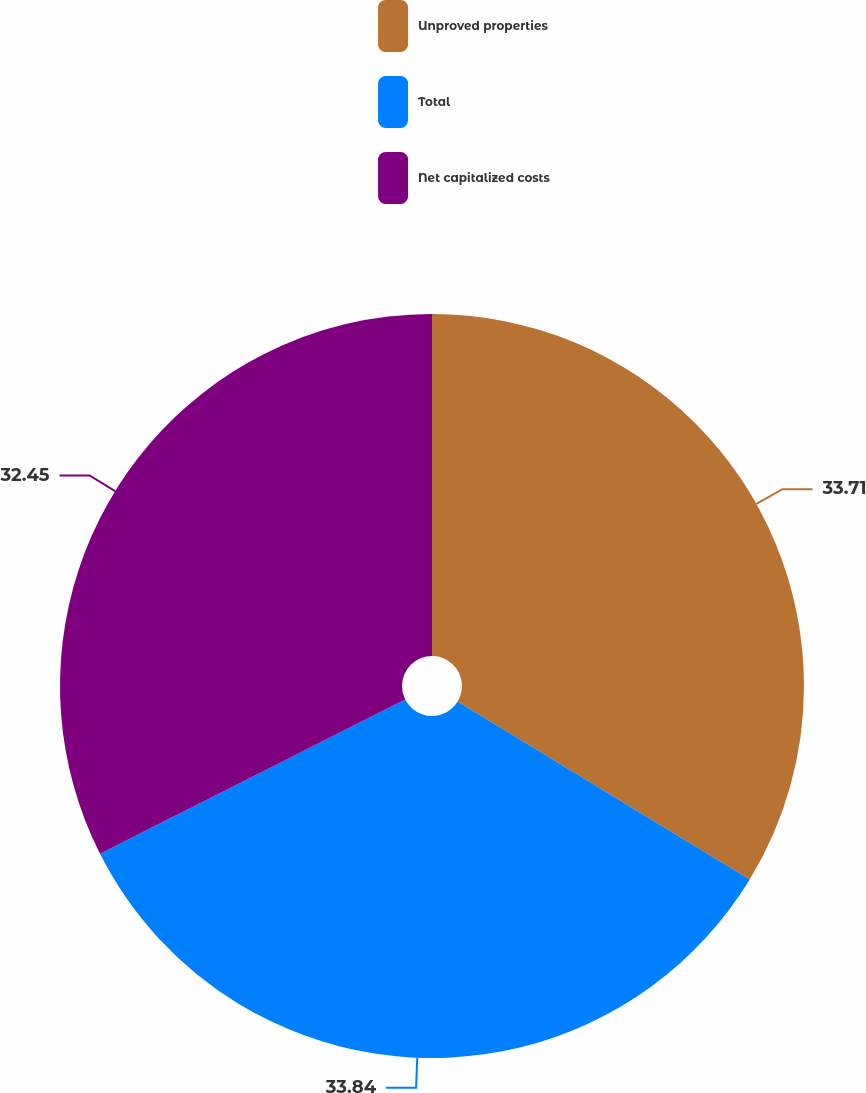<chart> <loc_0><loc_0><loc_500><loc_500><pie_chart><fcel>Unproved properties<fcel>Total<fcel>Net capitalized costs<nl><fcel>33.71%<fcel>33.84%<fcel>32.45%<nl></chart> 